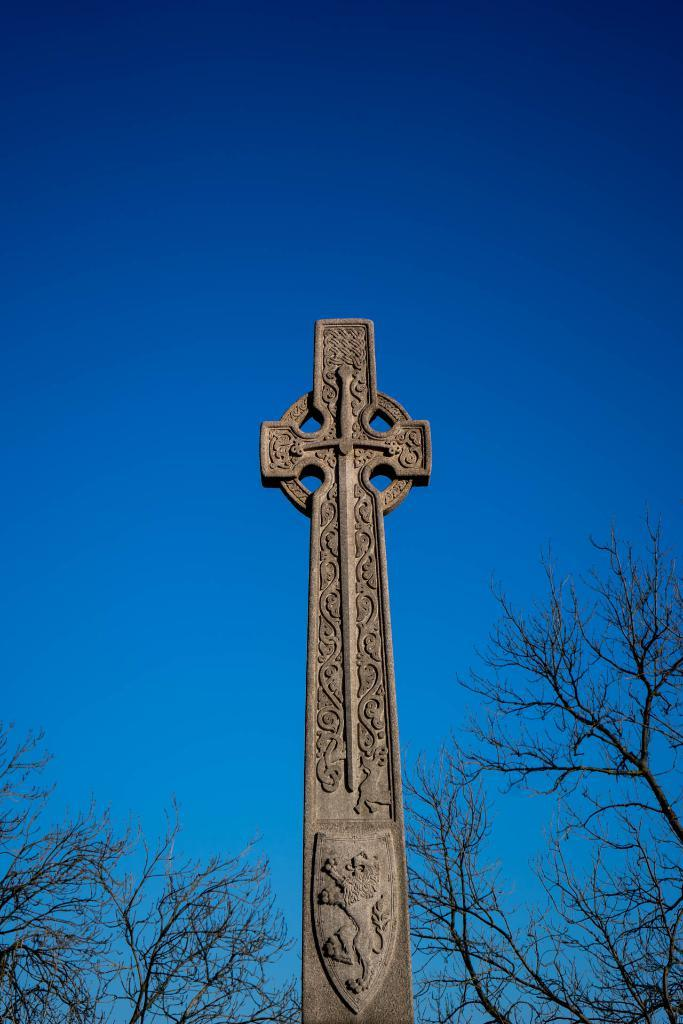What is the main subject in the image? There is a cross in the image. What can be seen in the background of the image? There are trees and the sky visible in the background of the image. Where is the celery located in the image? There is no celery present in the image. What type of scarf is draped over the cross in the image? There is no scarf present in the image; it only features a cross and the background. 